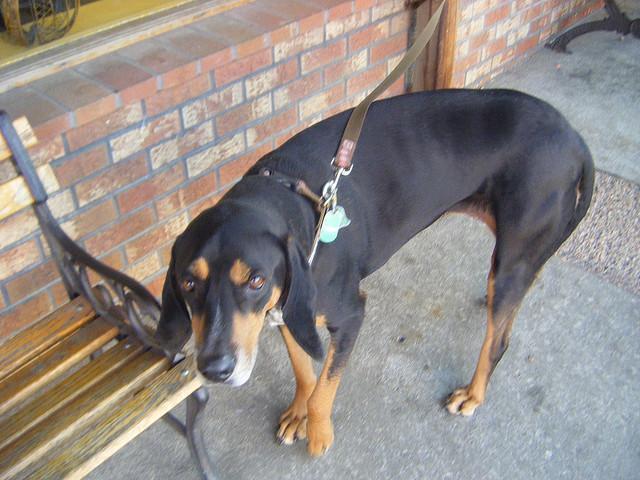How many benches are there?
Give a very brief answer. 1. 